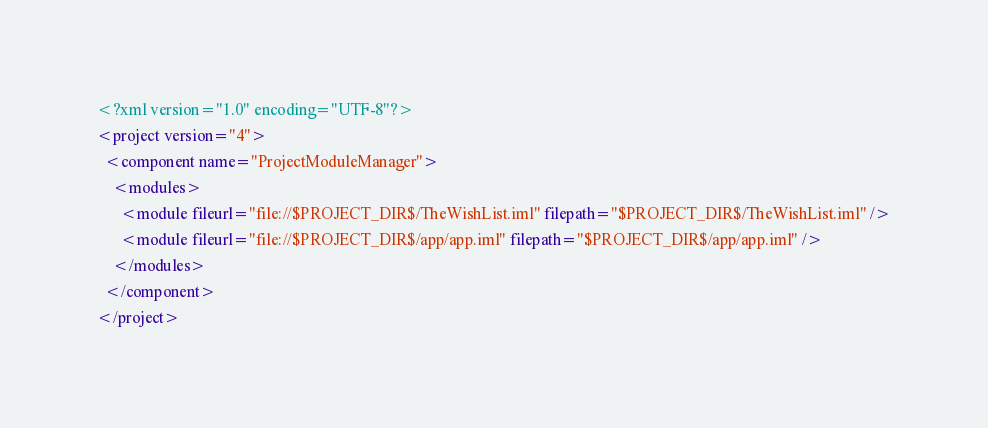Convert code to text. <code><loc_0><loc_0><loc_500><loc_500><_XML_><?xml version="1.0" encoding="UTF-8"?>
<project version="4">
  <component name="ProjectModuleManager">
    <modules>
      <module fileurl="file://$PROJECT_DIR$/TheWishList.iml" filepath="$PROJECT_DIR$/TheWishList.iml" />
      <module fileurl="file://$PROJECT_DIR$/app/app.iml" filepath="$PROJECT_DIR$/app/app.iml" />
    </modules>
  </component>
</project></code> 